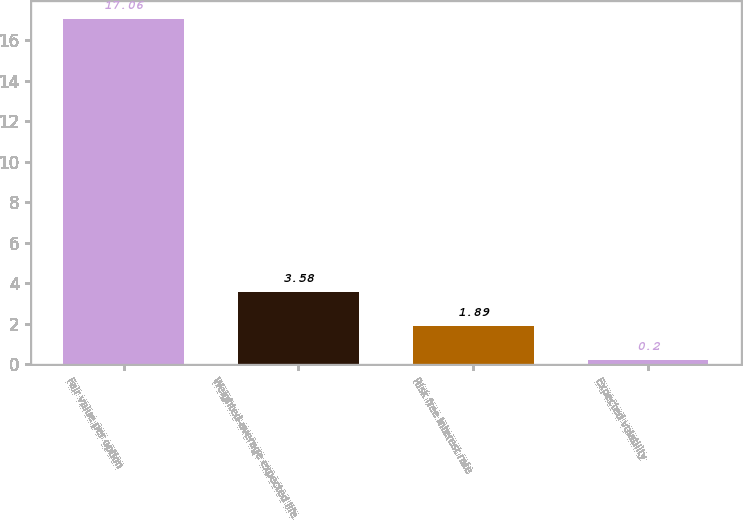Convert chart to OTSL. <chart><loc_0><loc_0><loc_500><loc_500><bar_chart><fcel>Fair value per option<fcel>Weighted-average expected life<fcel>Risk free interest rate<fcel>Expected volatility<nl><fcel>17.06<fcel>3.58<fcel>1.89<fcel>0.2<nl></chart> 